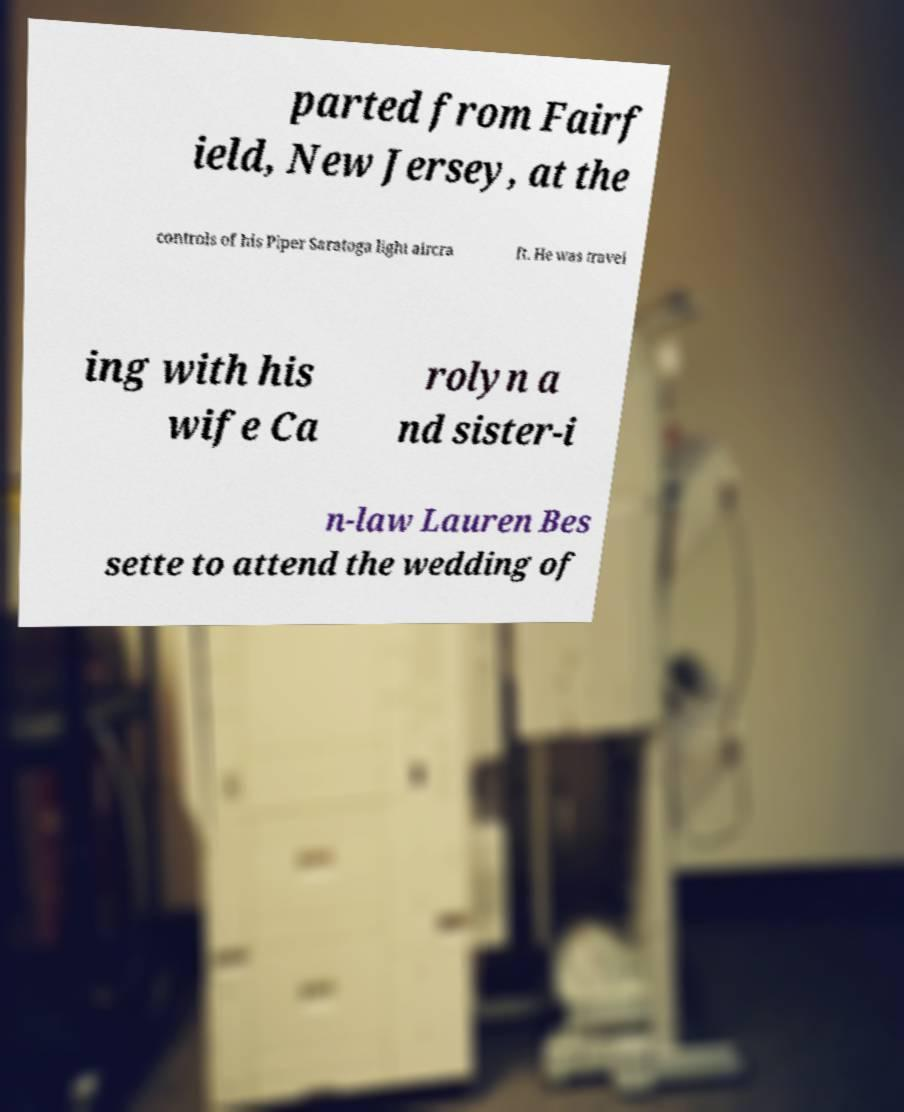There's text embedded in this image that I need extracted. Can you transcribe it verbatim? parted from Fairf ield, New Jersey, at the controls of his Piper Saratoga light aircra ft. He was travel ing with his wife Ca rolyn a nd sister-i n-law Lauren Bes sette to attend the wedding of 